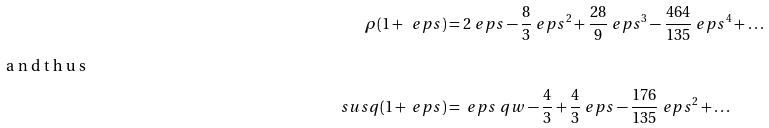<formula> <loc_0><loc_0><loc_500><loc_500>\rho ( 1 + \ e p s ) & = 2 \ e p s - \frac { 8 } { 3 } \ e p s ^ { 2 } + \frac { 2 8 } 9 \ e p s ^ { 3 } - \frac { 4 6 4 } { 1 3 5 } \ e p s ^ { 4 } + \dots \intertext { a n d t h u s } \ s u s q ( 1 + \ e p s ) & = { \ e p s } \ q w - \frac { 4 } { 3 } + \frac { 4 } { 3 } \ e p s - \frac { 1 7 6 } { 1 3 5 } \ e p s ^ { 2 } + \dots</formula> 